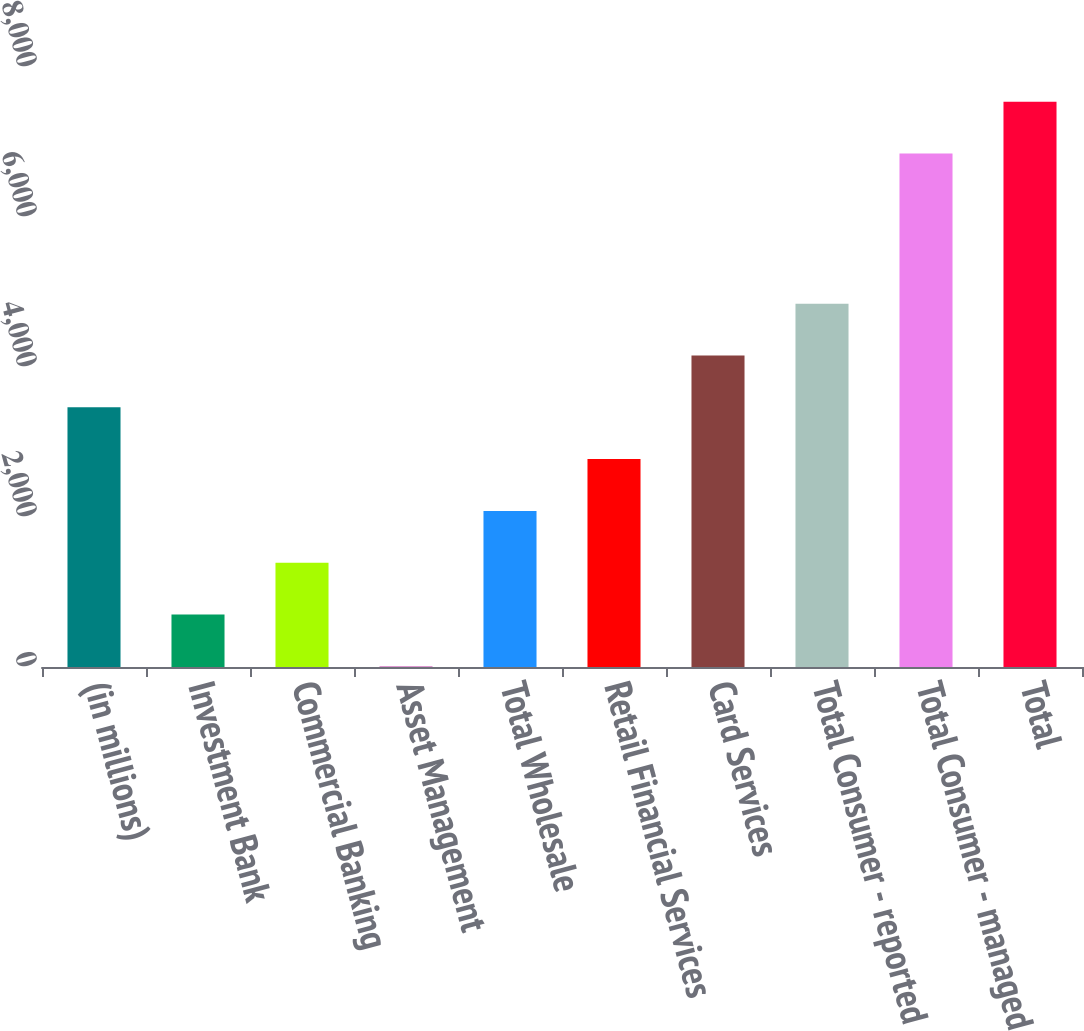Convert chart. <chart><loc_0><loc_0><loc_500><loc_500><bar_chart><fcel>(in millions)<fcel>Investment Bank<fcel>Commercial Banking<fcel>Asset Management<fcel>Total Wholesale<fcel>Retail Financial Services<fcel>Card Services<fcel>Total Consumer - reported<fcel>Total Consumer - managed<fcel>Total<nl><fcel>3463<fcel>699<fcel>1390<fcel>8<fcel>2081<fcel>2772<fcel>4154<fcel>4845<fcel>6846<fcel>7537<nl></chart> 